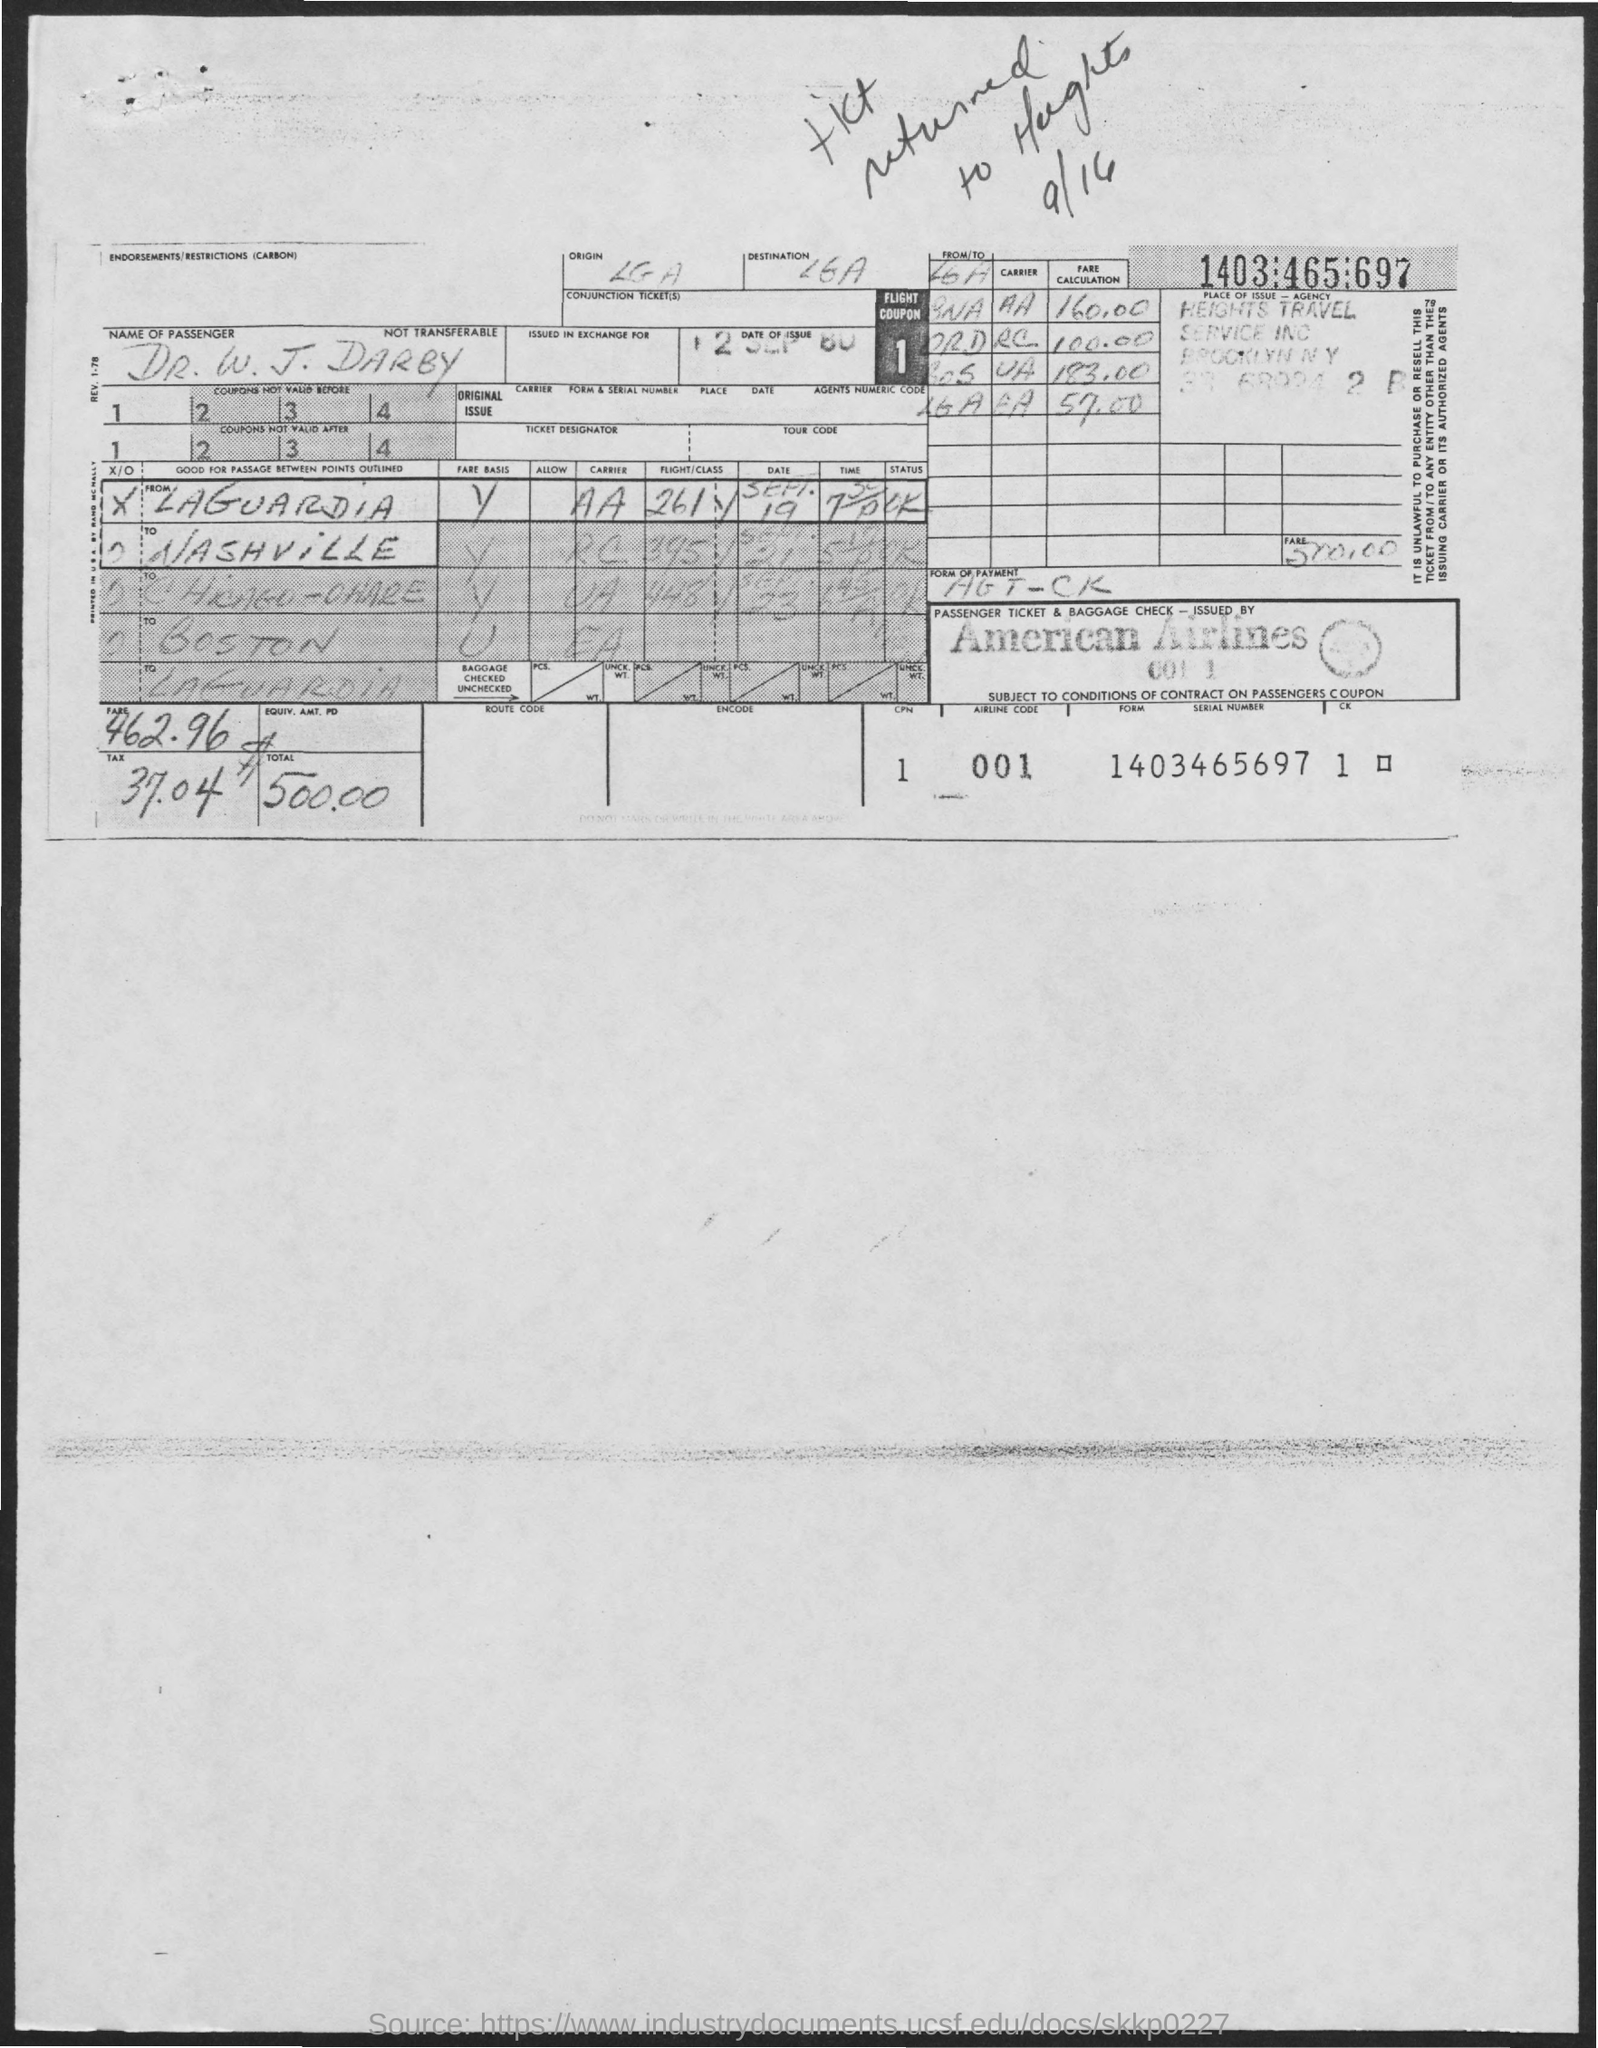Identify some key points in this picture. The name of the passenger is Dr. W. J. Darby. The tax amount is 37.04. The total amount is 500.00. The airline code is 001. 